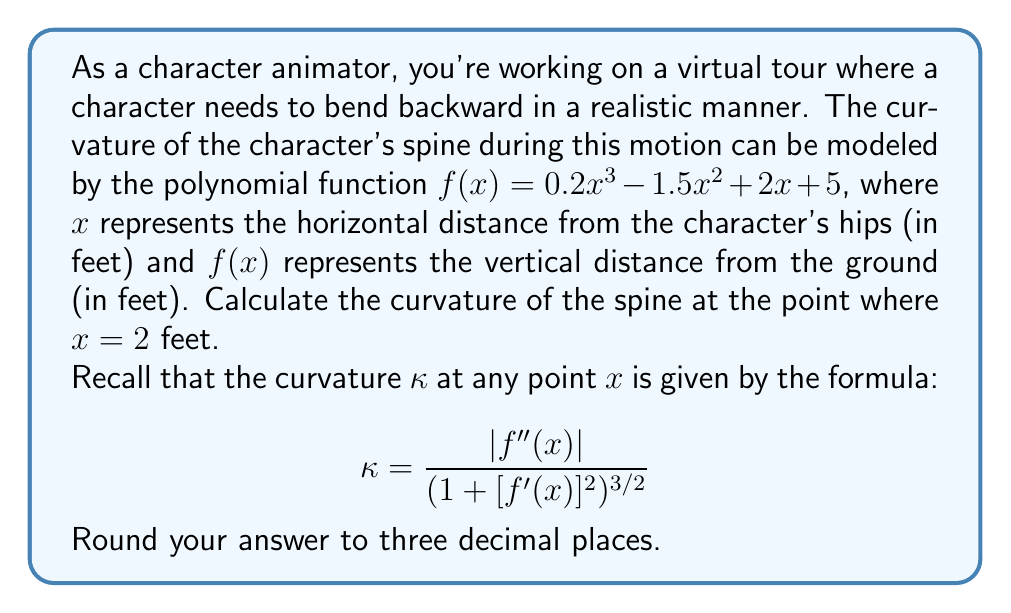What is the answer to this math problem? To solve this problem, we need to follow these steps:

1) First, we need to find $f'(x)$ and $f''(x)$:

   $f(x) = 0.2x^3 - 1.5x^2 + 2x + 5$
   $f'(x) = 0.6x^2 - 3x + 2$
   $f''(x) = 1.2x - 3$

2) Now, we need to evaluate $f'(x)$ and $f''(x)$ at $x = 2$:

   $f'(2) = 0.6(2)^2 - 3(2) + 2 = 2.4 - 6 + 2 = -1.6$
   $f''(2) = 1.2(2) - 3 = 2.4 - 3 = -0.6$

3) Next, we plug these values into the curvature formula:

   $$\kappa = \frac{|f''(x)|}{(1 + [f'(x)]^2)^{3/2}}$$

   $$\kappa = \frac{|-0.6|}{(1 + [-1.6]^2)^{3/2}}$$

4) Simplify:
   
   $$\kappa = \frac{0.6}{(1 + 2.56)^{3/2}} = \frac{0.6}{3.56^{3/2}}$$

5) Calculate the final result:

   $$\kappa \approx 0.089$$

6) Rounding to three decimal places:

   $$\kappa \approx 0.089$$
Answer: The curvature of the character's spine at $x = 2$ feet is approximately 0.089. 